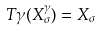Convert formula to latex. <formula><loc_0><loc_0><loc_500><loc_500>T \gamma ( X _ { \sigma } ^ { \gamma } ) = X _ { \sigma }</formula> 